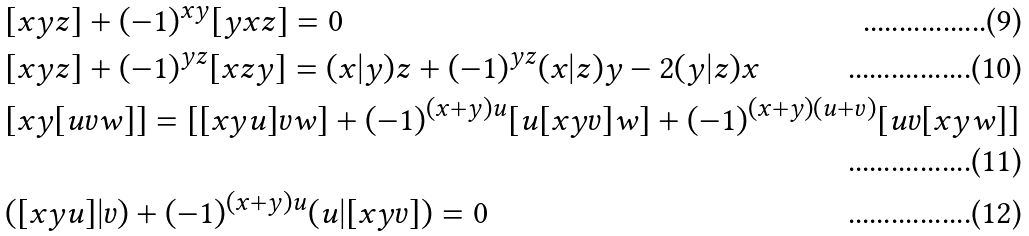Convert formula to latex. <formula><loc_0><loc_0><loc_500><loc_500>& [ x y z ] + ( - 1 ) ^ { x y } [ y x z ] = 0 \\ & [ x y z ] + ( - 1 ) ^ { y z } [ x z y ] = ( x | y ) z + ( - 1 ) ^ { y z } ( x | z ) y - 2 ( y | z ) x \\ & [ x y [ u v w ] ] = [ [ x y u ] v w ] + ( - 1 ) ^ { ( x + y ) u } [ u [ x y v ] w ] + ( - 1 ) ^ { ( x + y ) ( u + v ) } [ u v [ x y w ] ] \\ & ( [ x y u ] | v ) + ( - 1 ) ^ { ( x + y ) u } ( u | [ x y v ] ) = 0</formula> 